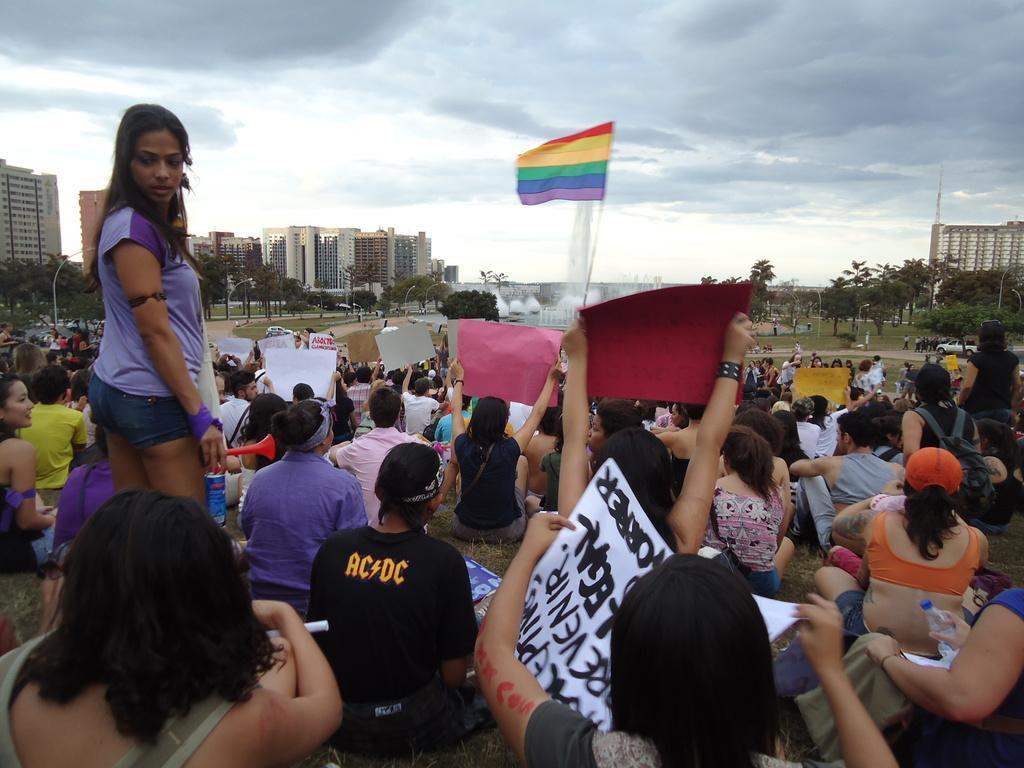Can you describe this image briefly? In this at front people are sitting on the ground by holding the banners. In front of them there is a flag, fountain. At the background there are trees, building and sky. 